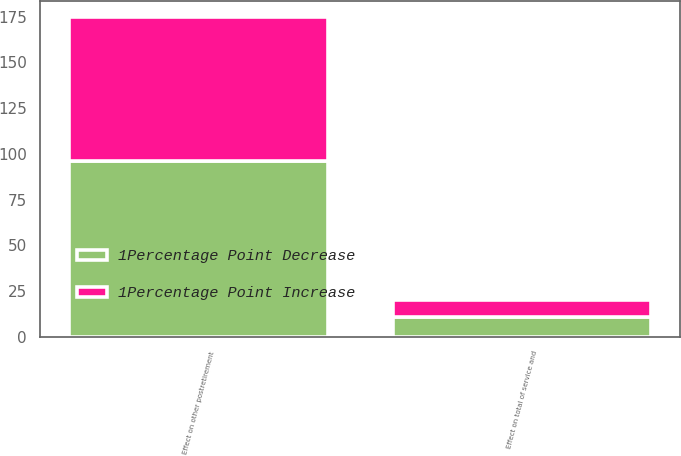Convert chart. <chart><loc_0><loc_0><loc_500><loc_500><stacked_bar_chart><ecel><fcel>Effect on total of service and<fcel>Effect on other postretirement<nl><fcel>1Percentage Point Decrease<fcel>11<fcel>96<nl><fcel>1Percentage Point Increase<fcel>9<fcel>79<nl></chart> 